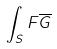Convert formula to latex. <formula><loc_0><loc_0><loc_500><loc_500>\int _ { S } F \overline { G }</formula> 